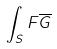Convert formula to latex. <formula><loc_0><loc_0><loc_500><loc_500>\int _ { S } F \overline { G }</formula> 